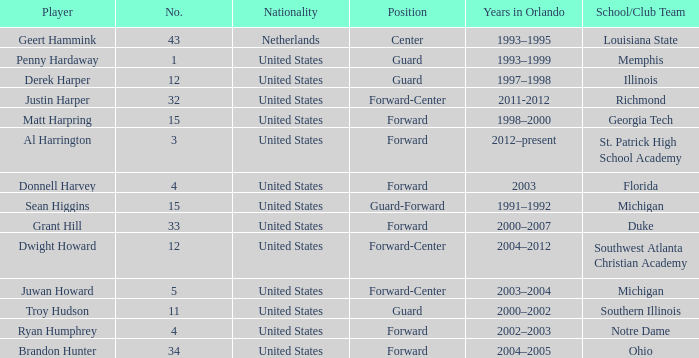What school did Dwight Howard play for Southwest Atlanta Christian Academy. 